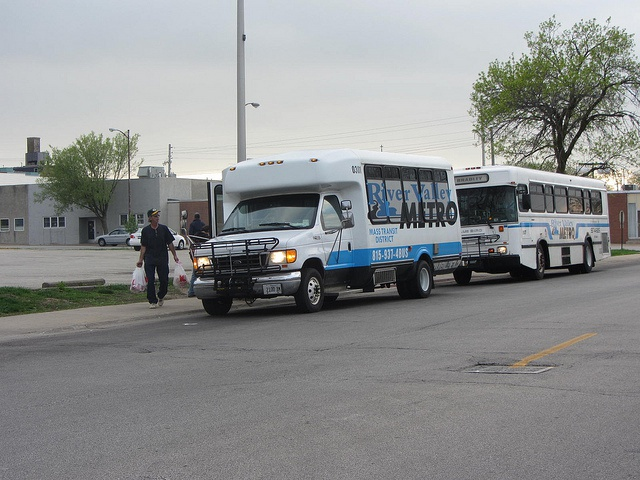Describe the objects in this image and their specific colors. I can see truck in lightgray, black, darkgray, and gray tones, bus in lightgray, black, darkgray, and gray tones, bus in lightgray, black, darkgray, and gray tones, people in lightgray, black, and gray tones, and car in lightgray, gray, black, and darkgray tones in this image. 